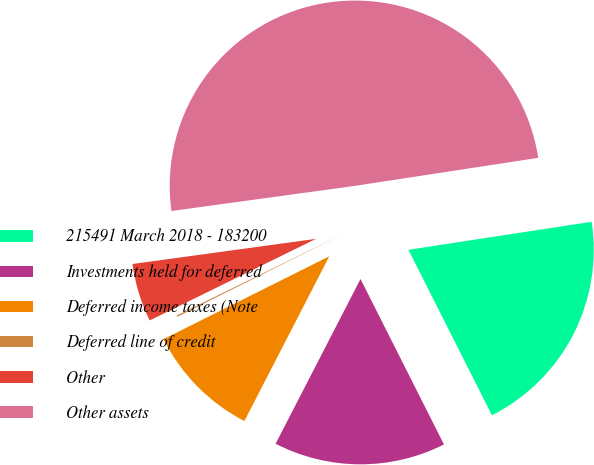Convert chart to OTSL. <chart><loc_0><loc_0><loc_500><loc_500><pie_chart><fcel>215491 March 2018 - 183200<fcel>Investments held for deferred<fcel>Deferred income taxes (Note<fcel>Deferred line of credit<fcel>Other<fcel>Other assets<nl><fcel>19.98%<fcel>15.01%<fcel>10.05%<fcel>0.12%<fcel>5.09%<fcel>49.75%<nl></chart> 